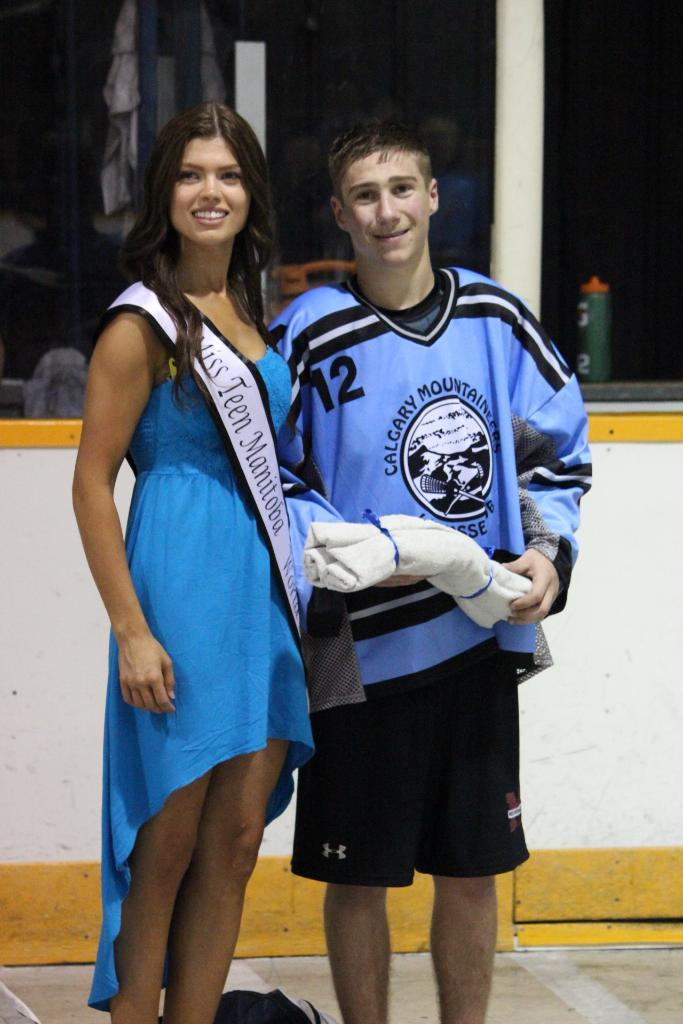Provide a one-sentence caption for the provided image. Miss Teen Manitoba poses with a hockey player in blue jersey. 